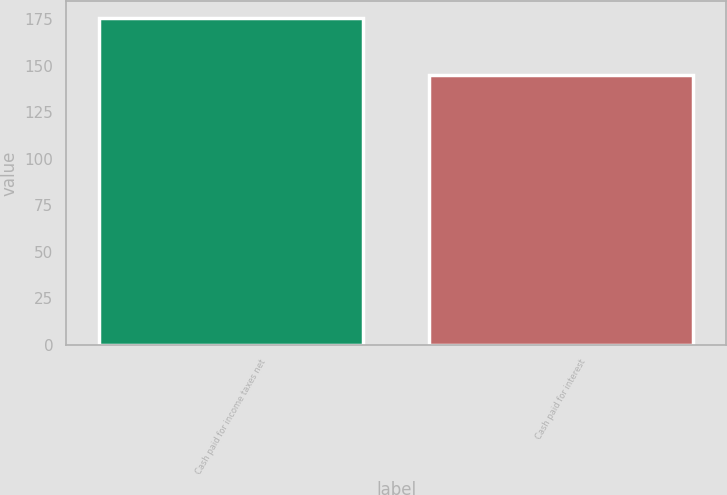Convert chart. <chart><loc_0><loc_0><loc_500><loc_500><bar_chart><fcel>Cash paid for income taxes net<fcel>Cash paid for interest<nl><fcel>176<fcel>145<nl></chart> 